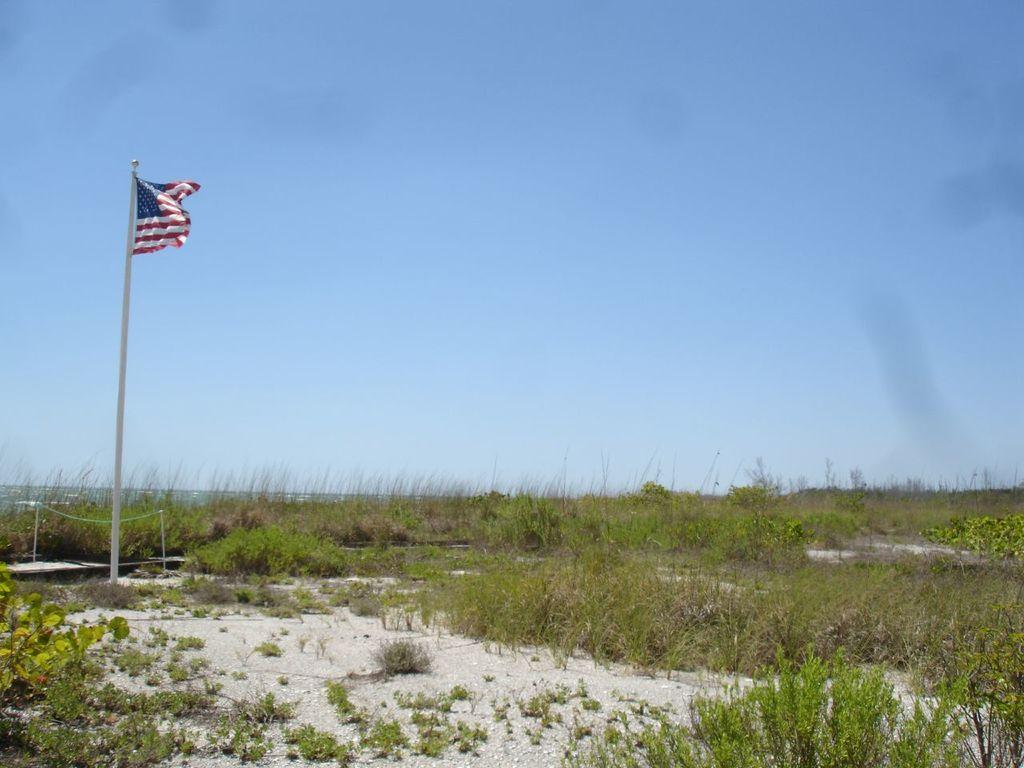What is located on the left side of the image? There is a flag on the left side of the image. What can be seen at the bottom of the image? There is grass at the bottom of the image. What is visible in the background of the image? The sky and plants are visible in the background of the image. Does the queen exist in the image? There is no queen present in the image. What type of power is being demonstrated by the plants in the image? The plants in the image are not demonstrating any power; they are simply visible in the background. 